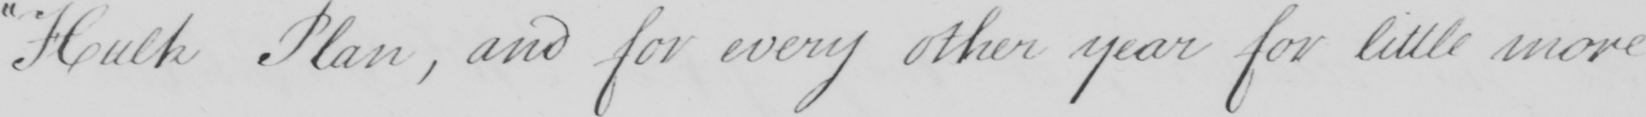Please transcribe the handwritten text in this image. " Hulk Plan , and for every other year and for little more 